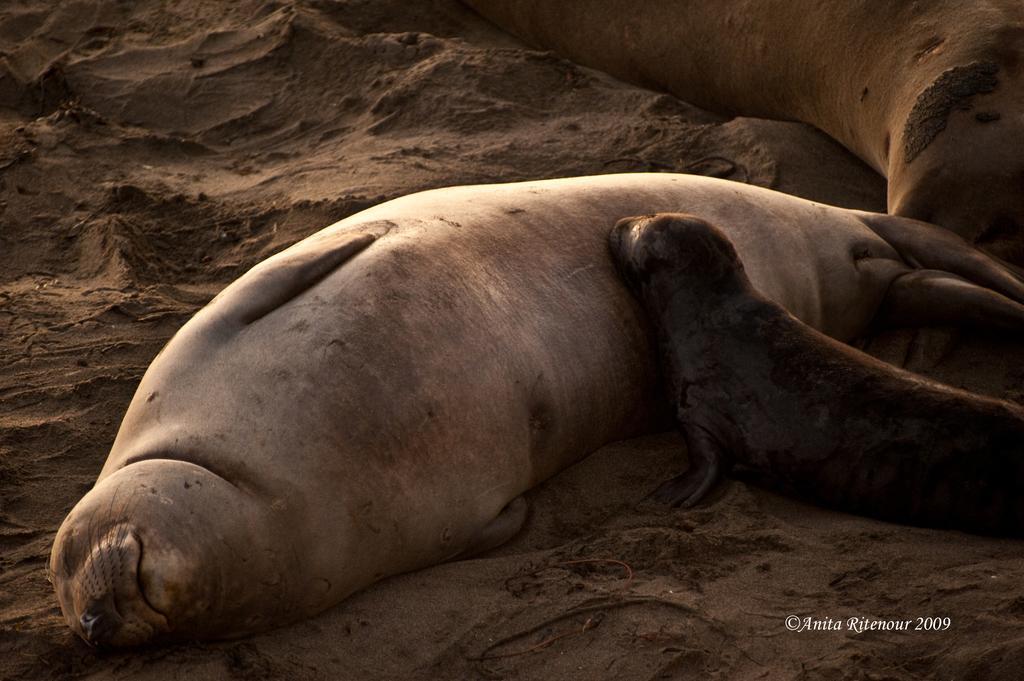How would you summarize this image in a sentence or two? In this picture there is a seal in the center of the image, on a muddy area and there is another seal on the right side of the image. 